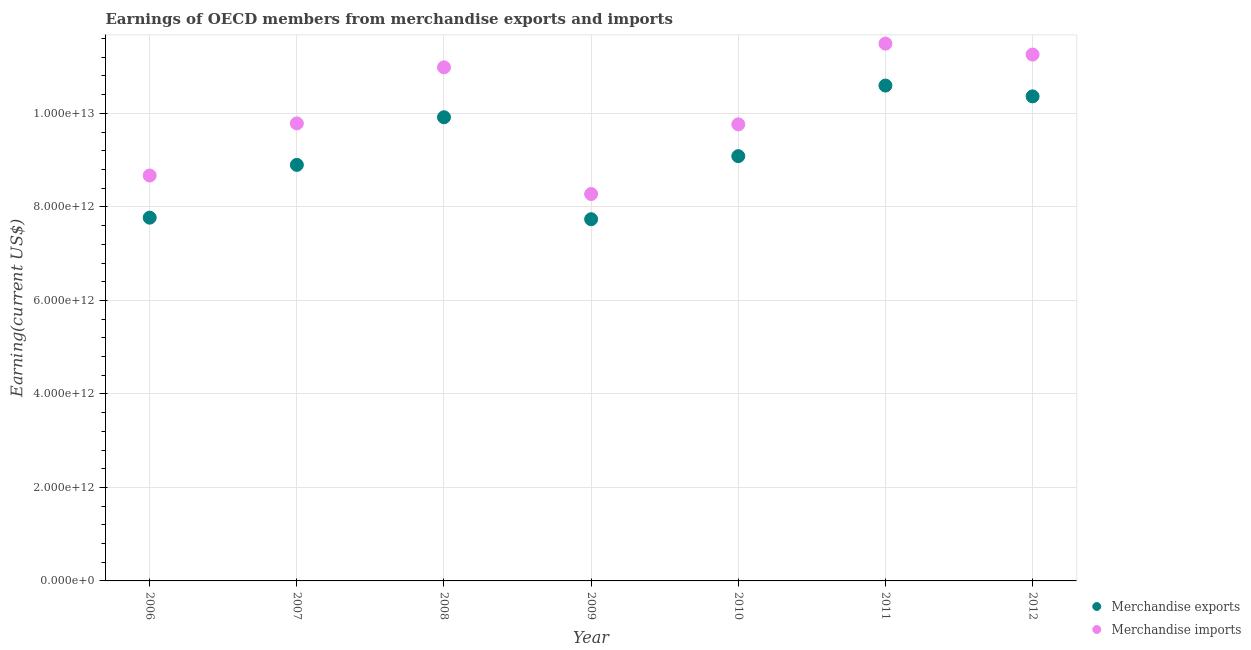How many different coloured dotlines are there?
Your answer should be compact. 2. What is the earnings from merchandise exports in 2010?
Ensure brevity in your answer.  9.09e+12. Across all years, what is the maximum earnings from merchandise exports?
Your answer should be compact. 1.06e+13. Across all years, what is the minimum earnings from merchandise exports?
Keep it short and to the point. 7.74e+12. In which year was the earnings from merchandise imports minimum?
Give a very brief answer. 2009. What is the total earnings from merchandise imports in the graph?
Provide a succinct answer. 7.02e+13. What is the difference between the earnings from merchandise exports in 2007 and that in 2008?
Provide a short and direct response. -1.02e+12. What is the difference between the earnings from merchandise exports in 2011 and the earnings from merchandise imports in 2008?
Your answer should be very brief. -3.90e+11. What is the average earnings from merchandise exports per year?
Your response must be concise. 9.20e+12. In the year 2012, what is the difference between the earnings from merchandise exports and earnings from merchandise imports?
Provide a short and direct response. -8.94e+11. In how many years, is the earnings from merchandise imports greater than 3200000000000 US$?
Keep it short and to the point. 7. What is the ratio of the earnings from merchandise exports in 2010 to that in 2011?
Provide a succinct answer. 0.86. Is the earnings from merchandise imports in 2011 less than that in 2012?
Provide a short and direct response. No. What is the difference between the highest and the second highest earnings from merchandise exports?
Your answer should be very brief. 2.31e+11. What is the difference between the highest and the lowest earnings from merchandise imports?
Offer a terse response. 3.22e+12. Is the sum of the earnings from merchandise exports in 2007 and 2008 greater than the maximum earnings from merchandise imports across all years?
Provide a succinct answer. Yes. Does the earnings from merchandise imports monotonically increase over the years?
Your answer should be compact. No. Is the earnings from merchandise exports strictly less than the earnings from merchandise imports over the years?
Offer a very short reply. Yes. How many dotlines are there?
Your answer should be compact. 2. What is the difference between two consecutive major ticks on the Y-axis?
Give a very brief answer. 2.00e+12. Are the values on the major ticks of Y-axis written in scientific E-notation?
Offer a terse response. Yes. Does the graph contain any zero values?
Ensure brevity in your answer.  No. Does the graph contain grids?
Offer a very short reply. Yes. Where does the legend appear in the graph?
Give a very brief answer. Bottom right. How are the legend labels stacked?
Provide a short and direct response. Vertical. What is the title of the graph?
Your response must be concise. Earnings of OECD members from merchandise exports and imports. Does "Constant 2005 US$" appear as one of the legend labels in the graph?
Offer a very short reply. No. What is the label or title of the X-axis?
Ensure brevity in your answer.  Year. What is the label or title of the Y-axis?
Your answer should be very brief. Earning(current US$). What is the Earning(current US$) in Merchandise exports in 2006?
Keep it short and to the point. 7.77e+12. What is the Earning(current US$) of Merchandise imports in 2006?
Make the answer very short. 8.67e+12. What is the Earning(current US$) in Merchandise exports in 2007?
Make the answer very short. 8.90e+12. What is the Earning(current US$) in Merchandise imports in 2007?
Your answer should be very brief. 9.79e+12. What is the Earning(current US$) in Merchandise exports in 2008?
Provide a succinct answer. 9.92e+12. What is the Earning(current US$) in Merchandise imports in 2008?
Provide a succinct answer. 1.10e+13. What is the Earning(current US$) of Merchandise exports in 2009?
Offer a terse response. 7.74e+12. What is the Earning(current US$) in Merchandise imports in 2009?
Provide a short and direct response. 8.28e+12. What is the Earning(current US$) in Merchandise exports in 2010?
Your answer should be very brief. 9.09e+12. What is the Earning(current US$) of Merchandise imports in 2010?
Offer a terse response. 9.77e+12. What is the Earning(current US$) in Merchandise exports in 2011?
Ensure brevity in your answer.  1.06e+13. What is the Earning(current US$) of Merchandise imports in 2011?
Your answer should be compact. 1.15e+13. What is the Earning(current US$) in Merchandise exports in 2012?
Offer a very short reply. 1.04e+13. What is the Earning(current US$) in Merchandise imports in 2012?
Offer a terse response. 1.13e+13. Across all years, what is the maximum Earning(current US$) in Merchandise exports?
Provide a short and direct response. 1.06e+13. Across all years, what is the maximum Earning(current US$) of Merchandise imports?
Give a very brief answer. 1.15e+13. Across all years, what is the minimum Earning(current US$) in Merchandise exports?
Keep it short and to the point. 7.74e+12. Across all years, what is the minimum Earning(current US$) in Merchandise imports?
Give a very brief answer. 8.28e+12. What is the total Earning(current US$) in Merchandise exports in the graph?
Your answer should be very brief. 6.44e+13. What is the total Earning(current US$) in Merchandise imports in the graph?
Your answer should be compact. 7.02e+13. What is the difference between the Earning(current US$) in Merchandise exports in 2006 and that in 2007?
Your response must be concise. -1.13e+12. What is the difference between the Earning(current US$) of Merchandise imports in 2006 and that in 2007?
Offer a terse response. -1.11e+12. What is the difference between the Earning(current US$) in Merchandise exports in 2006 and that in 2008?
Make the answer very short. -2.15e+12. What is the difference between the Earning(current US$) in Merchandise imports in 2006 and that in 2008?
Offer a very short reply. -2.31e+12. What is the difference between the Earning(current US$) in Merchandise exports in 2006 and that in 2009?
Provide a succinct answer. 3.33e+1. What is the difference between the Earning(current US$) of Merchandise imports in 2006 and that in 2009?
Provide a succinct answer. 3.95e+11. What is the difference between the Earning(current US$) of Merchandise exports in 2006 and that in 2010?
Ensure brevity in your answer.  -1.32e+12. What is the difference between the Earning(current US$) of Merchandise imports in 2006 and that in 2010?
Your answer should be compact. -1.09e+12. What is the difference between the Earning(current US$) in Merchandise exports in 2006 and that in 2011?
Give a very brief answer. -2.83e+12. What is the difference between the Earning(current US$) in Merchandise imports in 2006 and that in 2011?
Your answer should be very brief. -2.82e+12. What is the difference between the Earning(current US$) of Merchandise exports in 2006 and that in 2012?
Offer a terse response. -2.59e+12. What is the difference between the Earning(current US$) of Merchandise imports in 2006 and that in 2012?
Ensure brevity in your answer.  -2.59e+12. What is the difference between the Earning(current US$) in Merchandise exports in 2007 and that in 2008?
Ensure brevity in your answer.  -1.02e+12. What is the difference between the Earning(current US$) of Merchandise imports in 2007 and that in 2008?
Keep it short and to the point. -1.20e+12. What is the difference between the Earning(current US$) in Merchandise exports in 2007 and that in 2009?
Your response must be concise. 1.16e+12. What is the difference between the Earning(current US$) of Merchandise imports in 2007 and that in 2009?
Offer a terse response. 1.51e+12. What is the difference between the Earning(current US$) in Merchandise exports in 2007 and that in 2010?
Give a very brief answer. -1.87e+11. What is the difference between the Earning(current US$) of Merchandise imports in 2007 and that in 2010?
Offer a terse response. 1.98e+1. What is the difference between the Earning(current US$) in Merchandise exports in 2007 and that in 2011?
Keep it short and to the point. -1.70e+12. What is the difference between the Earning(current US$) of Merchandise imports in 2007 and that in 2011?
Ensure brevity in your answer.  -1.71e+12. What is the difference between the Earning(current US$) in Merchandise exports in 2007 and that in 2012?
Your response must be concise. -1.47e+12. What is the difference between the Earning(current US$) in Merchandise imports in 2007 and that in 2012?
Ensure brevity in your answer.  -1.47e+12. What is the difference between the Earning(current US$) in Merchandise exports in 2008 and that in 2009?
Offer a terse response. 2.18e+12. What is the difference between the Earning(current US$) in Merchandise imports in 2008 and that in 2009?
Your answer should be very brief. 2.71e+12. What is the difference between the Earning(current US$) of Merchandise exports in 2008 and that in 2010?
Give a very brief answer. 8.32e+11. What is the difference between the Earning(current US$) of Merchandise imports in 2008 and that in 2010?
Offer a terse response. 1.22e+12. What is the difference between the Earning(current US$) in Merchandise exports in 2008 and that in 2011?
Provide a short and direct response. -6.78e+11. What is the difference between the Earning(current US$) of Merchandise imports in 2008 and that in 2011?
Your answer should be very brief. -5.06e+11. What is the difference between the Earning(current US$) in Merchandise exports in 2008 and that in 2012?
Keep it short and to the point. -4.47e+11. What is the difference between the Earning(current US$) of Merchandise imports in 2008 and that in 2012?
Provide a succinct answer. -2.73e+11. What is the difference between the Earning(current US$) of Merchandise exports in 2009 and that in 2010?
Offer a terse response. -1.35e+12. What is the difference between the Earning(current US$) of Merchandise imports in 2009 and that in 2010?
Keep it short and to the point. -1.49e+12. What is the difference between the Earning(current US$) of Merchandise exports in 2009 and that in 2011?
Provide a short and direct response. -2.86e+12. What is the difference between the Earning(current US$) in Merchandise imports in 2009 and that in 2011?
Keep it short and to the point. -3.22e+12. What is the difference between the Earning(current US$) in Merchandise exports in 2009 and that in 2012?
Provide a short and direct response. -2.63e+12. What is the difference between the Earning(current US$) in Merchandise imports in 2009 and that in 2012?
Your answer should be very brief. -2.98e+12. What is the difference between the Earning(current US$) of Merchandise exports in 2010 and that in 2011?
Provide a succinct answer. -1.51e+12. What is the difference between the Earning(current US$) in Merchandise imports in 2010 and that in 2011?
Keep it short and to the point. -1.73e+12. What is the difference between the Earning(current US$) of Merchandise exports in 2010 and that in 2012?
Provide a short and direct response. -1.28e+12. What is the difference between the Earning(current US$) of Merchandise imports in 2010 and that in 2012?
Offer a terse response. -1.49e+12. What is the difference between the Earning(current US$) in Merchandise exports in 2011 and that in 2012?
Your answer should be very brief. 2.31e+11. What is the difference between the Earning(current US$) of Merchandise imports in 2011 and that in 2012?
Ensure brevity in your answer.  2.33e+11. What is the difference between the Earning(current US$) of Merchandise exports in 2006 and the Earning(current US$) of Merchandise imports in 2007?
Provide a succinct answer. -2.02e+12. What is the difference between the Earning(current US$) of Merchandise exports in 2006 and the Earning(current US$) of Merchandise imports in 2008?
Your answer should be very brief. -3.22e+12. What is the difference between the Earning(current US$) of Merchandise exports in 2006 and the Earning(current US$) of Merchandise imports in 2009?
Keep it short and to the point. -5.06e+11. What is the difference between the Earning(current US$) in Merchandise exports in 2006 and the Earning(current US$) in Merchandise imports in 2010?
Provide a succinct answer. -2.00e+12. What is the difference between the Earning(current US$) in Merchandise exports in 2006 and the Earning(current US$) in Merchandise imports in 2011?
Your answer should be compact. -3.72e+12. What is the difference between the Earning(current US$) in Merchandise exports in 2006 and the Earning(current US$) in Merchandise imports in 2012?
Offer a terse response. -3.49e+12. What is the difference between the Earning(current US$) of Merchandise exports in 2007 and the Earning(current US$) of Merchandise imports in 2008?
Ensure brevity in your answer.  -2.09e+12. What is the difference between the Earning(current US$) of Merchandise exports in 2007 and the Earning(current US$) of Merchandise imports in 2009?
Provide a short and direct response. 6.23e+11. What is the difference between the Earning(current US$) in Merchandise exports in 2007 and the Earning(current US$) in Merchandise imports in 2010?
Ensure brevity in your answer.  -8.67e+11. What is the difference between the Earning(current US$) of Merchandise exports in 2007 and the Earning(current US$) of Merchandise imports in 2011?
Your answer should be compact. -2.59e+12. What is the difference between the Earning(current US$) in Merchandise exports in 2007 and the Earning(current US$) in Merchandise imports in 2012?
Provide a succinct answer. -2.36e+12. What is the difference between the Earning(current US$) in Merchandise exports in 2008 and the Earning(current US$) in Merchandise imports in 2009?
Provide a succinct answer. 1.64e+12. What is the difference between the Earning(current US$) in Merchandise exports in 2008 and the Earning(current US$) in Merchandise imports in 2010?
Your answer should be very brief. 1.51e+11. What is the difference between the Earning(current US$) in Merchandise exports in 2008 and the Earning(current US$) in Merchandise imports in 2011?
Provide a short and direct response. -1.57e+12. What is the difference between the Earning(current US$) in Merchandise exports in 2008 and the Earning(current US$) in Merchandise imports in 2012?
Provide a succinct answer. -1.34e+12. What is the difference between the Earning(current US$) of Merchandise exports in 2009 and the Earning(current US$) of Merchandise imports in 2010?
Keep it short and to the point. -2.03e+12. What is the difference between the Earning(current US$) in Merchandise exports in 2009 and the Earning(current US$) in Merchandise imports in 2011?
Offer a terse response. -3.76e+12. What is the difference between the Earning(current US$) of Merchandise exports in 2009 and the Earning(current US$) of Merchandise imports in 2012?
Offer a very short reply. -3.52e+12. What is the difference between the Earning(current US$) in Merchandise exports in 2010 and the Earning(current US$) in Merchandise imports in 2011?
Make the answer very short. -2.41e+12. What is the difference between the Earning(current US$) of Merchandise exports in 2010 and the Earning(current US$) of Merchandise imports in 2012?
Keep it short and to the point. -2.17e+12. What is the difference between the Earning(current US$) in Merchandise exports in 2011 and the Earning(current US$) in Merchandise imports in 2012?
Provide a short and direct response. -6.63e+11. What is the average Earning(current US$) of Merchandise exports per year?
Make the answer very short. 9.20e+12. What is the average Earning(current US$) in Merchandise imports per year?
Your response must be concise. 1.00e+13. In the year 2006, what is the difference between the Earning(current US$) in Merchandise exports and Earning(current US$) in Merchandise imports?
Offer a terse response. -9.01e+11. In the year 2007, what is the difference between the Earning(current US$) of Merchandise exports and Earning(current US$) of Merchandise imports?
Your response must be concise. -8.87e+11. In the year 2008, what is the difference between the Earning(current US$) in Merchandise exports and Earning(current US$) in Merchandise imports?
Ensure brevity in your answer.  -1.07e+12. In the year 2009, what is the difference between the Earning(current US$) in Merchandise exports and Earning(current US$) in Merchandise imports?
Your answer should be compact. -5.39e+11. In the year 2010, what is the difference between the Earning(current US$) of Merchandise exports and Earning(current US$) of Merchandise imports?
Provide a short and direct response. -6.80e+11. In the year 2011, what is the difference between the Earning(current US$) in Merchandise exports and Earning(current US$) in Merchandise imports?
Offer a very short reply. -8.97e+11. In the year 2012, what is the difference between the Earning(current US$) of Merchandise exports and Earning(current US$) of Merchandise imports?
Keep it short and to the point. -8.94e+11. What is the ratio of the Earning(current US$) of Merchandise exports in 2006 to that in 2007?
Ensure brevity in your answer.  0.87. What is the ratio of the Earning(current US$) of Merchandise imports in 2006 to that in 2007?
Provide a short and direct response. 0.89. What is the ratio of the Earning(current US$) in Merchandise exports in 2006 to that in 2008?
Your answer should be compact. 0.78. What is the ratio of the Earning(current US$) of Merchandise imports in 2006 to that in 2008?
Your response must be concise. 0.79. What is the ratio of the Earning(current US$) of Merchandise exports in 2006 to that in 2009?
Offer a very short reply. 1. What is the ratio of the Earning(current US$) in Merchandise imports in 2006 to that in 2009?
Your answer should be very brief. 1.05. What is the ratio of the Earning(current US$) of Merchandise exports in 2006 to that in 2010?
Provide a succinct answer. 0.86. What is the ratio of the Earning(current US$) of Merchandise imports in 2006 to that in 2010?
Offer a very short reply. 0.89. What is the ratio of the Earning(current US$) of Merchandise exports in 2006 to that in 2011?
Ensure brevity in your answer.  0.73. What is the ratio of the Earning(current US$) in Merchandise imports in 2006 to that in 2011?
Ensure brevity in your answer.  0.75. What is the ratio of the Earning(current US$) of Merchandise exports in 2006 to that in 2012?
Your response must be concise. 0.75. What is the ratio of the Earning(current US$) of Merchandise imports in 2006 to that in 2012?
Your response must be concise. 0.77. What is the ratio of the Earning(current US$) in Merchandise exports in 2007 to that in 2008?
Your response must be concise. 0.9. What is the ratio of the Earning(current US$) of Merchandise imports in 2007 to that in 2008?
Offer a very short reply. 0.89. What is the ratio of the Earning(current US$) in Merchandise exports in 2007 to that in 2009?
Your answer should be very brief. 1.15. What is the ratio of the Earning(current US$) of Merchandise imports in 2007 to that in 2009?
Keep it short and to the point. 1.18. What is the ratio of the Earning(current US$) of Merchandise exports in 2007 to that in 2010?
Your answer should be compact. 0.98. What is the ratio of the Earning(current US$) of Merchandise exports in 2007 to that in 2011?
Offer a terse response. 0.84. What is the ratio of the Earning(current US$) in Merchandise imports in 2007 to that in 2011?
Offer a very short reply. 0.85. What is the ratio of the Earning(current US$) of Merchandise exports in 2007 to that in 2012?
Provide a succinct answer. 0.86. What is the ratio of the Earning(current US$) in Merchandise imports in 2007 to that in 2012?
Your answer should be compact. 0.87. What is the ratio of the Earning(current US$) in Merchandise exports in 2008 to that in 2009?
Provide a succinct answer. 1.28. What is the ratio of the Earning(current US$) in Merchandise imports in 2008 to that in 2009?
Provide a short and direct response. 1.33. What is the ratio of the Earning(current US$) of Merchandise exports in 2008 to that in 2010?
Your response must be concise. 1.09. What is the ratio of the Earning(current US$) in Merchandise imports in 2008 to that in 2010?
Offer a very short reply. 1.12. What is the ratio of the Earning(current US$) in Merchandise exports in 2008 to that in 2011?
Your answer should be very brief. 0.94. What is the ratio of the Earning(current US$) of Merchandise imports in 2008 to that in 2011?
Provide a succinct answer. 0.96. What is the ratio of the Earning(current US$) in Merchandise exports in 2008 to that in 2012?
Make the answer very short. 0.96. What is the ratio of the Earning(current US$) in Merchandise imports in 2008 to that in 2012?
Your response must be concise. 0.98. What is the ratio of the Earning(current US$) in Merchandise exports in 2009 to that in 2010?
Make the answer very short. 0.85. What is the ratio of the Earning(current US$) in Merchandise imports in 2009 to that in 2010?
Give a very brief answer. 0.85. What is the ratio of the Earning(current US$) in Merchandise exports in 2009 to that in 2011?
Give a very brief answer. 0.73. What is the ratio of the Earning(current US$) in Merchandise imports in 2009 to that in 2011?
Keep it short and to the point. 0.72. What is the ratio of the Earning(current US$) in Merchandise exports in 2009 to that in 2012?
Provide a short and direct response. 0.75. What is the ratio of the Earning(current US$) in Merchandise imports in 2009 to that in 2012?
Your answer should be very brief. 0.74. What is the ratio of the Earning(current US$) of Merchandise exports in 2010 to that in 2011?
Ensure brevity in your answer.  0.86. What is the ratio of the Earning(current US$) in Merchandise imports in 2010 to that in 2011?
Your answer should be very brief. 0.85. What is the ratio of the Earning(current US$) of Merchandise exports in 2010 to that in 2012?
Your response must be concise. 0.88. What is the ratio of the Earning(current US$) of Merchandise imports in 2010 to that in 2012?
Ensure brevity in your answer.  0.87. What is the ratio of the Earning(current US$) of Merchandise exports in 2011 to that in 2012?
Your answer should be very brief. 1.02. What is the ratio of the Earning(current US$) of Merchandise imports in 2011 to that in 2012?
Ensure brevity in your answer.  1.02. What is the difference between the highest and the second highest Earning(current US$) of Merchandise exports?
Your answer should be very brief. 2.31e+11. What is the difference between the highest and the second highest Earning(current US$) of Merchandise imports?
Offer a terse response. 2.33e+11. What is the difference between the highest and the lowest Earning(current US$) of Merchandise exports?
Provide a short and direct response. 2.86e+12. What is the difference between the highest and the lowest Earning(current US$) in Merchandise imports?
Provide a succinct answer. 3.22e+12. 